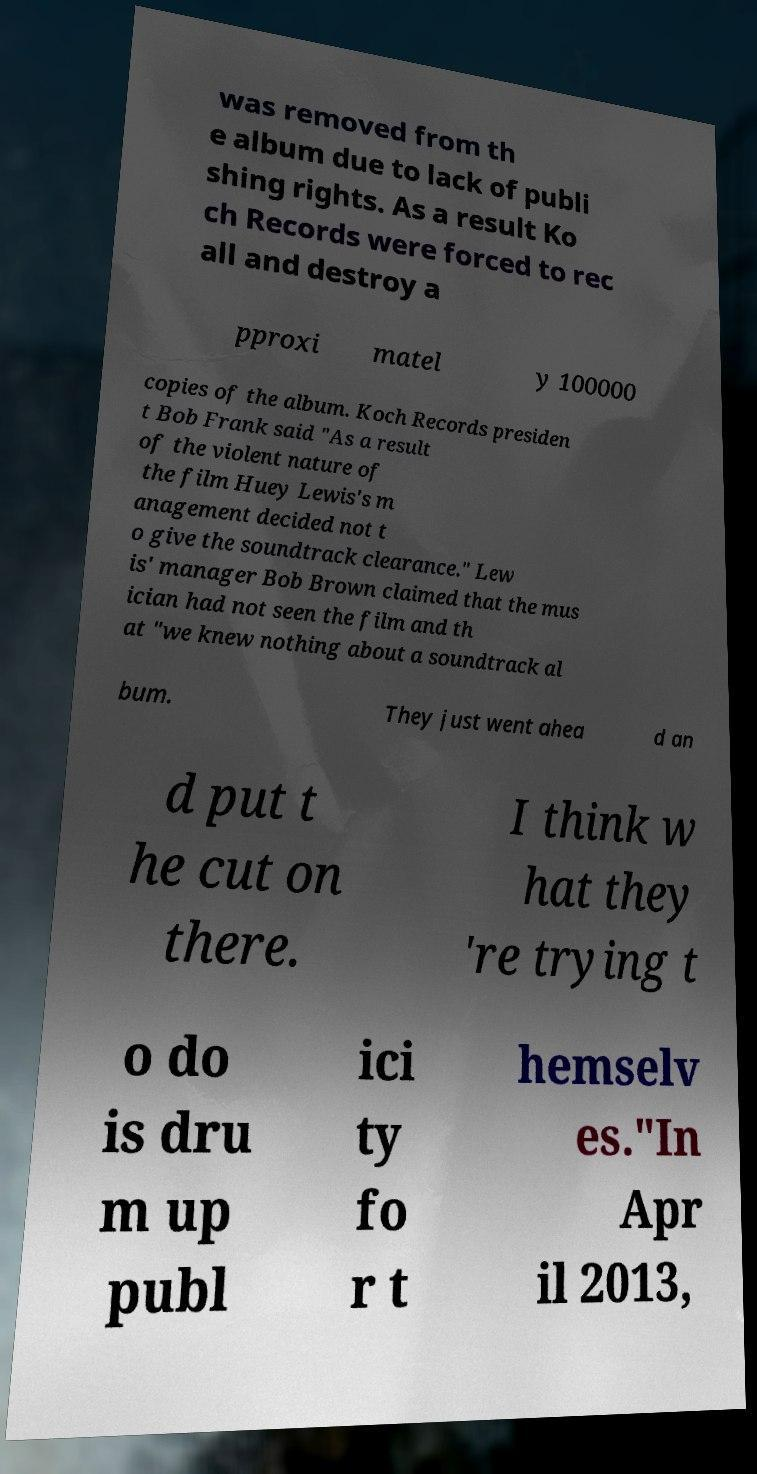I need the written content from this picture converted into text. Can you do that? was removed from th e album due to lack of publi shing rights. As a result Ko ch Records were forced to rec all and destroy a pproxi matel y 100000 copies of the album. Koch Records presiden t Bob Frank said "As a result of the violent nature of the film Huey Lewis's m anagement decided not t o give the soundtrack clearance." Lew is' manager Bob Brown claimed that the mus ician had not seen the film and th at "we knew nothing about a soundtrack al bum. They just went ahea d an d put t he cut on there. I think w hat they 're trying t o do is dru m up publ ici ty fo r t hemselv es."In Apr il 2013, 